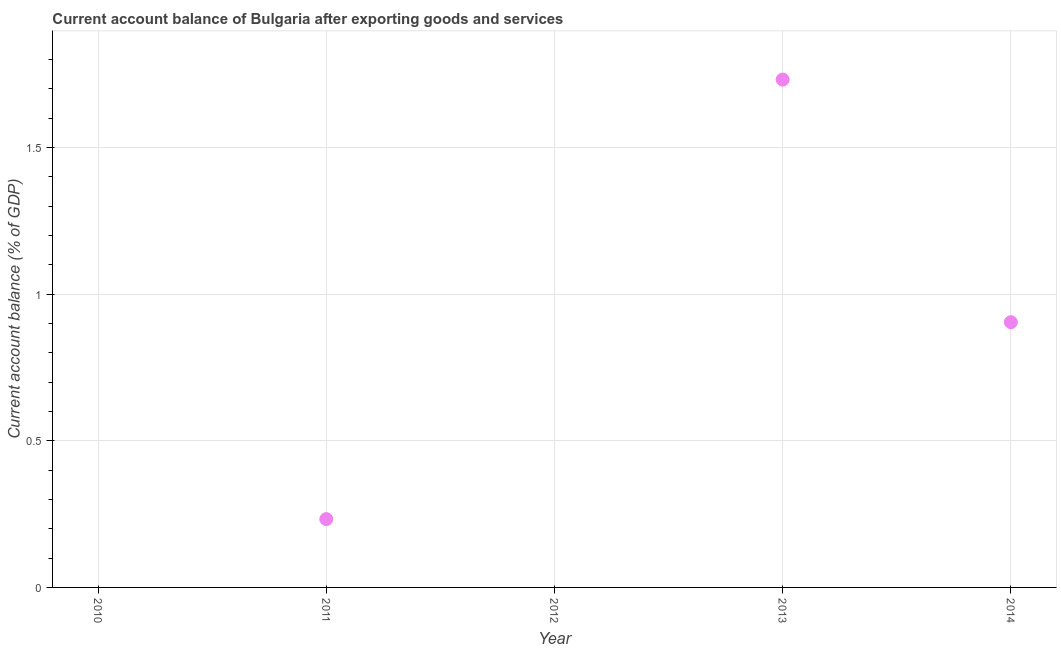Across all years, what is the maximum current account balance?
Your response must be concise. 1.73. In which year was the current account balance maximum?
Ensure brevity in your answer.  2013. What is the sum of the current account balance?
Your answer should be compact. 2.87. What is the difference between the current account balance in 2013 and 2014?
Make the answer very short. 0.83. What is the average current account balance per year?
Your answer should be compact. 0.57. What is the median current account balance?
Offer a terse response. 0.23. What is the ratio of the current account balance in 2011 to that in 2013?
Offer a terse response. 0.13. Is the difference between the current account balance in 2011 and 2014 greater than the difference between any two years?
Provide a succinct answer. No. What is the difference between the highest and the second highest current account balance?
Make the answer very short. 0.83. What is the difference between the highest and the lowest current account balance?
Provide a short and direct response. 1.73. In how many years, is the current account balance greater than the average current account balance taken over all years?
Offer a very short reply. 2. Does the current account balance monotonically increase over the years?
Make the answer very short. No. How many dotlines are there?
Ensure brevity in your answer.  1. What is the difference between two consecutive major ticks on the Y-axis?
Your response must be concise. 0.5. Are the values on the major ticks of Y-axis written in scientific E-notation?
Give a very brief answer. No. Does the graph contain any zero values?
Give a very brief answer. Yes. Does the graph contain grids?
Give a very brief answer. Yes. What is the title of the graph?
Provide a short and direct response. Current account balance of Bulgaria after exporting goods and services. What is the label or title of the Y-axis?
Offer a terse response. Current account balance (% of GDP). What is the Current account balance (% of GDP) in 2011?
Give a very brief answer. 0.23. What is the Current account balance (% of GDP) in 2013?
Give a very brief answer. 1.73. What is the Current account balance (% of GDP) in 2014?
Your answer should be very brief. 0.9. What is the difference between the Current account balance (% of GDP) in 2011 and 2013?
Keep it short and to the point. -1.5. What is the difference between the Current account balance (% of GDP) in 2011 and 2014?
Provide a short and direct response. -0.67. What is the difference between the Current account balance (% of GDP) in 2013 and 2014?
Offer a terse response. 0.83. What is the ratio of the Current account balance (% of GDP) in 2011 to that in 2013?
Provide a succinct answer. 0.14. What is the ratio of the Current account balance (% of GDP) in 2011 to that in 2014?
Keep it short and to the point. 0.26. What is the ratio of the Current account balance (% of GDP) in 2013 to that in 2014?
Your response must be concise. 1.92. 